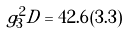<formula> <loc_0><loc_0><loc_500><loc_500>g _ { 3 } ^ { 2 } D = 4 2 . 6 \, ( 3 . 3 )</formula> 